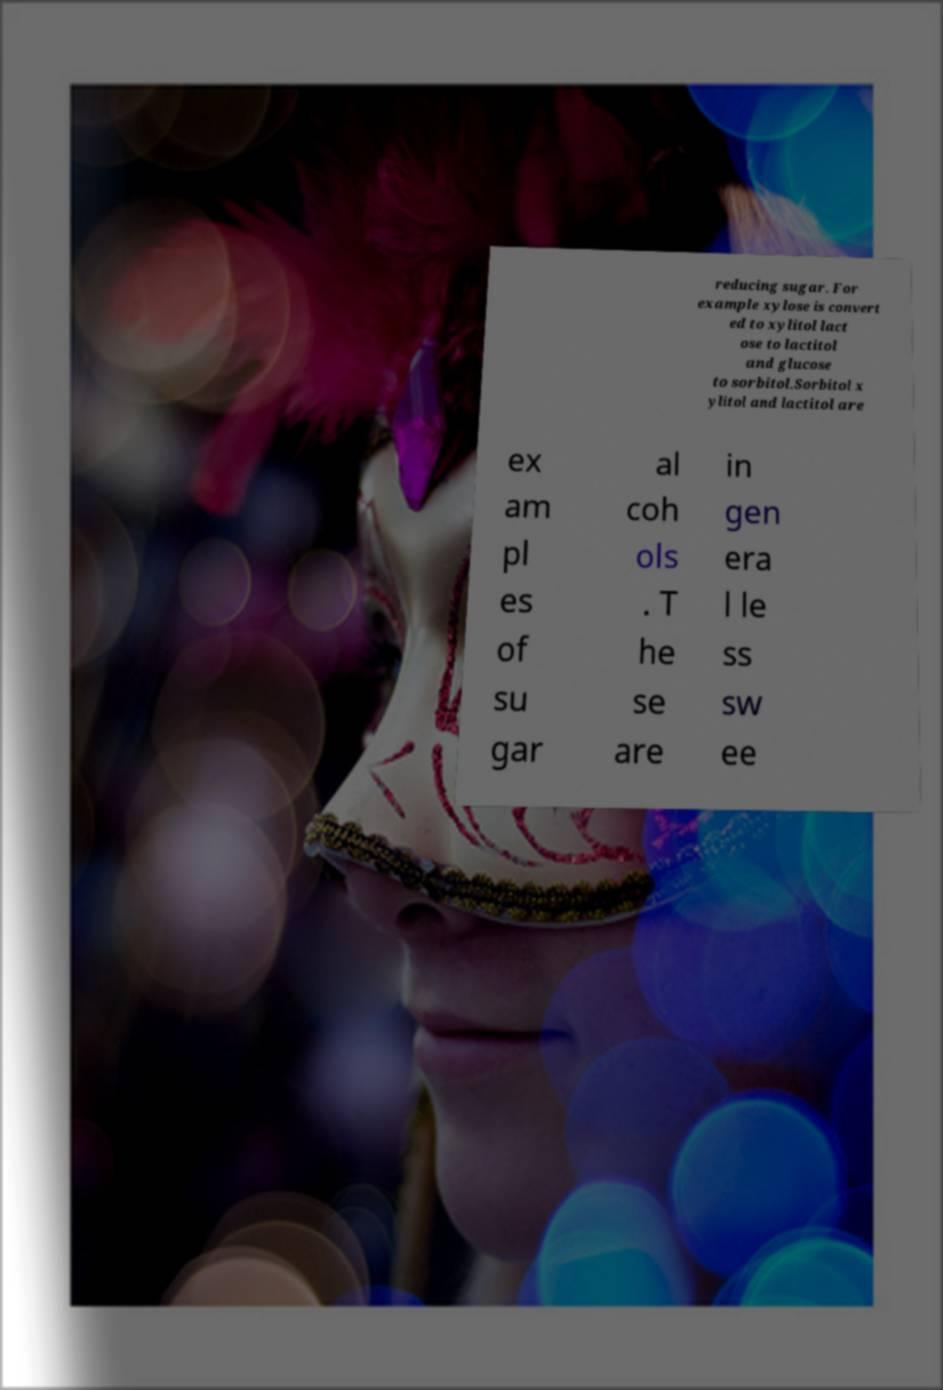What messages or text are displayed in this image? I need them in a readable, typed format. reducing sugar. For example xylose is convert ed to xylitol lact ose to lactitol and glucose to sorbitol.Sorbitol x ylitol and lactitol are ex am pl es of su gar al coh ols . T he se are in gen era l le ss sw ee 